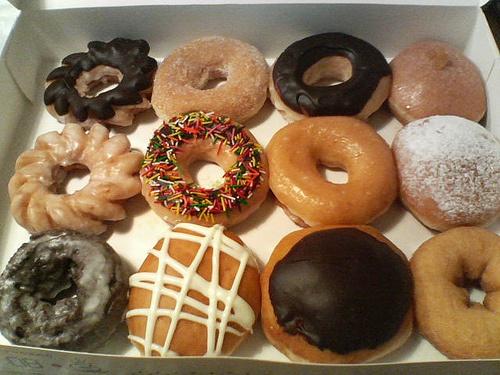Describe the objects in this image and their specific colors. I can see donut in ivory, black, maroon, and brown tones, donut in ivory, brown, beige, and tan tones, donut in ivory, black, and gray tones, donut in ivory, tan, and gray tones, and donut in ivory, red, and orange tones in this image. 